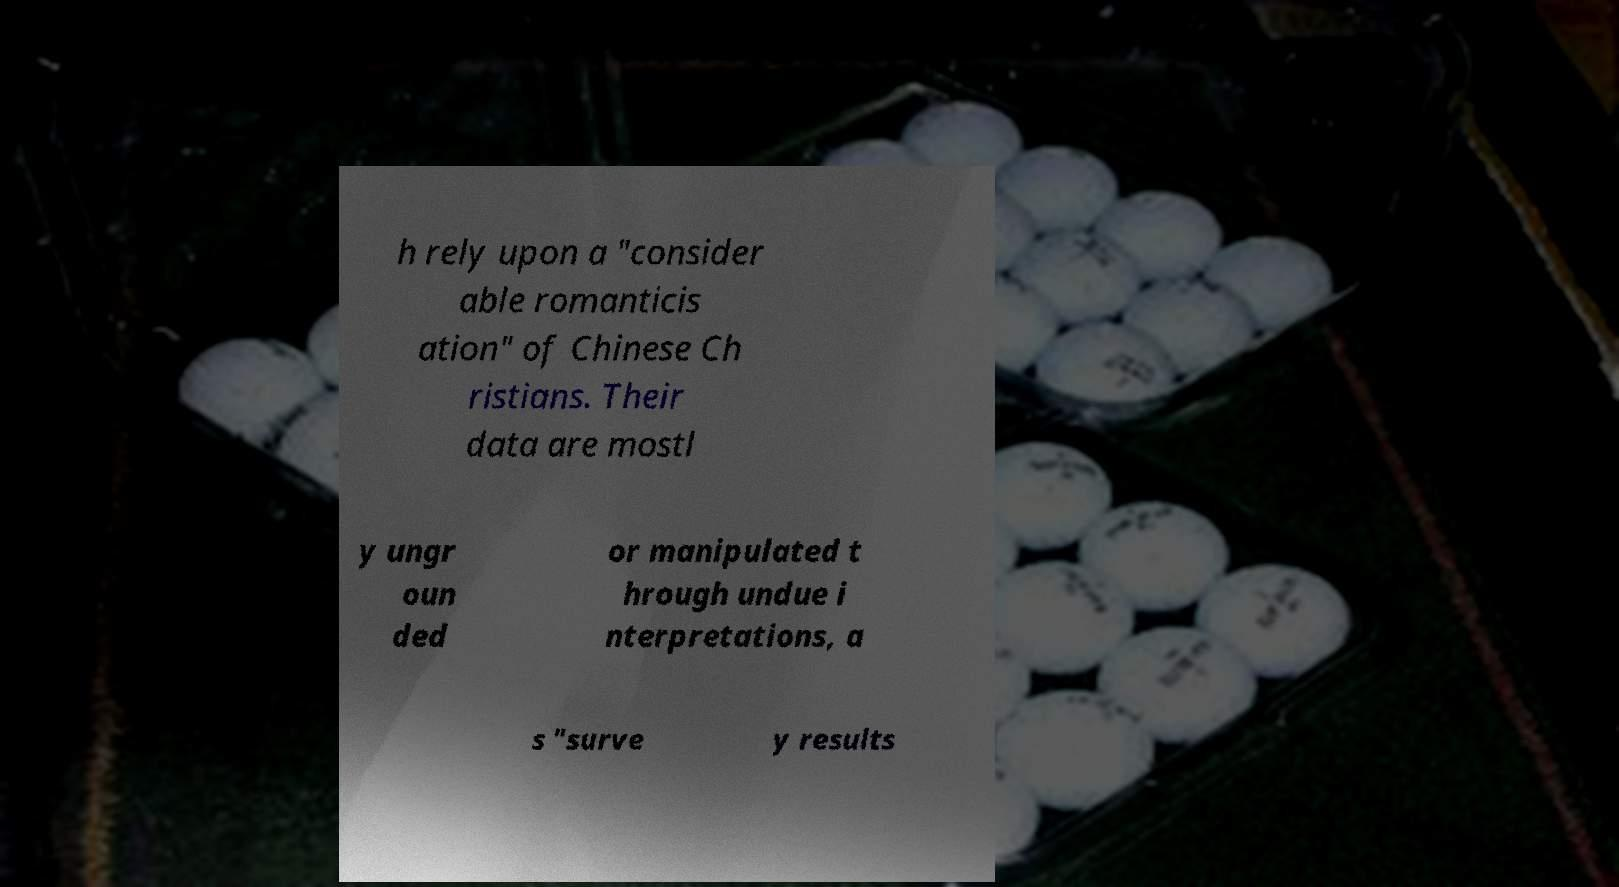Can you accurately transcribe the text from the provided image for me? h rely upon a "consider able romanticis ation" of Chinese Ch ristians. Their data are mostl y ungr oun ded or manipulated t hrough undue i nterpretations, a s "surve y results 